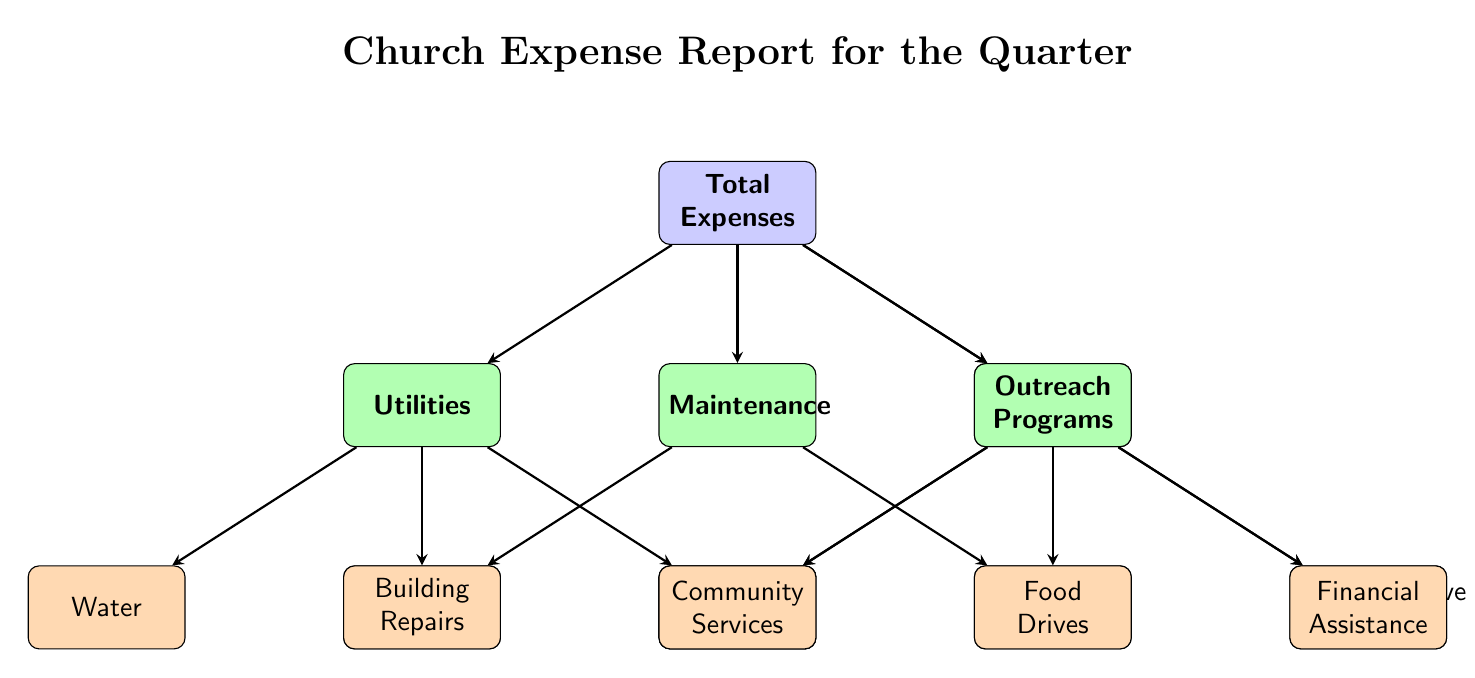What is the total number of expense categories? The diagram lists four main categories: Utilities, Maintenance, Staff Salaries, and Outreach Programs. Therefore, counting these four categories provides the total.
Answer: 4 What are the subcategories under Outreach Programs? The Outreach Programs category has three subcategories: Food Drives, Community Services, and Financial Assistance. These are directly connected to the Outreach Programs node in the diagram.
Answer: Food Drives, Community Services, Financial Assistance Which category includes Building Repairs? Building Repairs is a subcategory under the Maintenance category. By following the arrows from the total expenses downwards, we can trace Building Repairs to its respective category.
Answer: Maintenance How many subcategories fall under Utilities? The Utilities category has three subcategories. These are Electricity, Water, and Gas, connected directly by arrows. Counting these gives a total of three subcategories.
Answer: 3 What is the relationship between Staff Salaries and Pastor Salary? Pastor Salary is a subcategory that falls under the Staff Salaries category. The diagram illustrates this hierarchy with an arrow pointing from Staff Salaries to Pastor Salary.
Answer: Subcategory Which category has the most subcategories? The Outreach Programs category has the most subcategories with three: Food Drives, Community Services, and Financial Assistance. This is compared to the other categories which have fewer subcategories.
Answer: Outreach Programs What is the first level of expenses shown in the diagram? The first level of expenses includes the four main categories: Utilities, Maintenance, Staff Salaries, and Outreach Programs. These are the primary divisions of the total expenses.
Answer: Utilities, Maintenance, Staff Salaries, Outreach Programs How many nodes represent subcategories in total? The diagram has a total of eight subcategories: Electricity, Water, Gas, Building Repairs, Grounds-keeping, Pastor Salary, Administrative Staff, Food Drives, Community Services, and Financial Assistance. By counting each subcategory node, we arrive at the total.
Answer: 8 What expense category does Gas belong to? Gas is a subcategory under the Utilities category. Following the diagram flows downward, we see that Gas is directly linked to Utilities through an arrow.
Answer: Utilities 